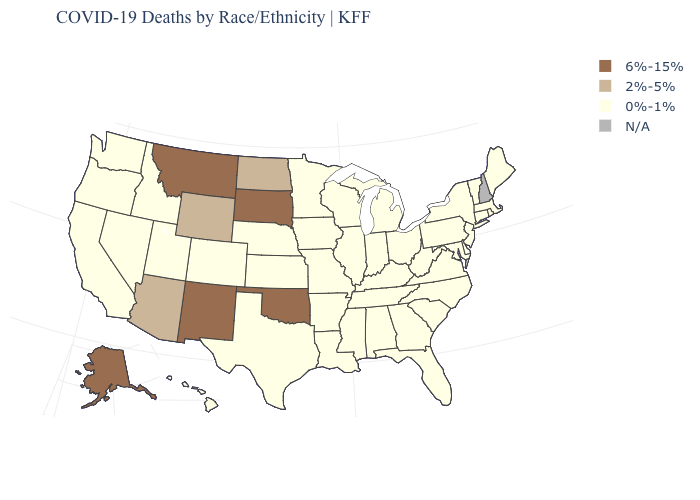Among the states that border Oklahoma , which have the highest value?
Answer briefly. New Mexico. How many symbols are there in the legend?
Write a very short answer. 4. What is the value of Montana?
Keep it brief. 6%-15%. Name the states that have a value in the range 2%-5%?
Concise answer only. Arizona, North Dakota, Wyoming. Which states have the highest value in the USA?
Quick response, please. Alaska, Montana, New Mexico, Oklahoma, South Dakota. Does Oklahoma have the highest value in the USA?
Keep it brief. Yes. What is the value of Massachusetts?
Concise answer only. 0%-1%. Name the states that have a value in the range 2%-5%?
Short answer required. Arizona, North Dakota, Wyoming. Among the states that border Washington , which have the highest value?
Write a very short answer. Idaho, Oregon. Does the first symbol in the legend represent the smallest category?
Be succinct. No. Name the states that have a value in the range 2%-5%?
Short answer required. Arizona, North Dakota, Wyoming. Name the states that have a value in the range 2%-5%?
Give a very brief answer. Arizona, North Dakota, Wyoming. Name the states that have a value in the range N/A?
Keep it brief. New Hampshire. 